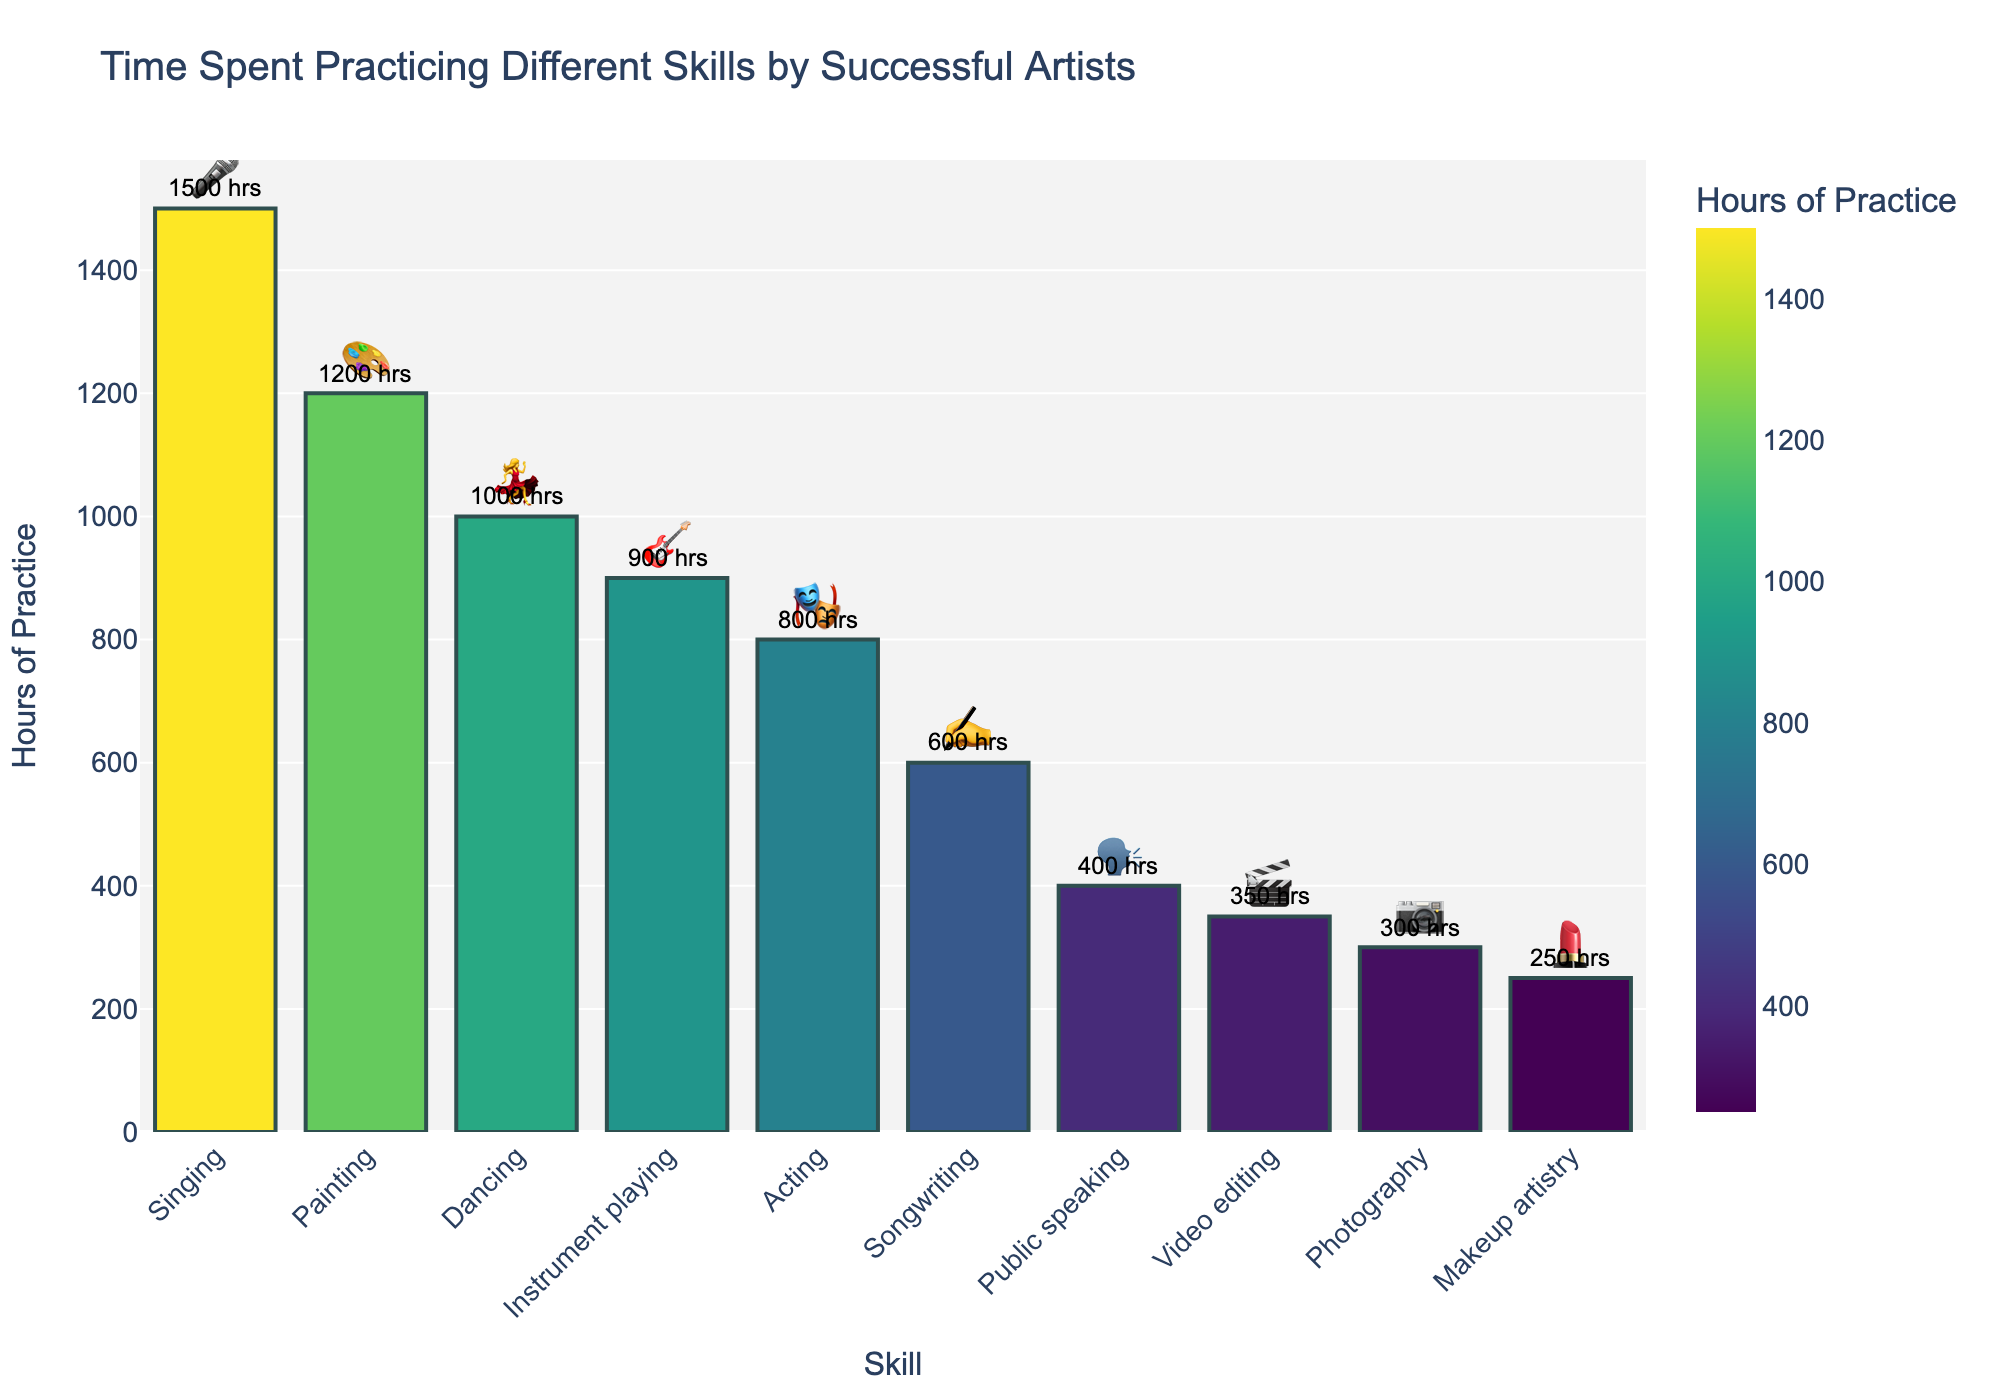what is the skill that artists spend the most hours on? The highest bar on the chart, which is labeled with emoji, represents the skill with the most hours; in this case, "🎤" for Singing.
Answer: Singing What skill has the least amount of practice hours? The lowest bar on the chart. When you look at the hours labeled on the bars, the smallest value is "💄" for Makeup artistry with 250 hours.
Answer: Makeup artistry How many more hours do artists spend on Singing compared to Painting? Locate the bars for Singing and Painting and note their hours: Singing has 1500 hours and Painting has 1200 hours. The difference is 1500 - 1200 = 300 hours.
Answer: 300 What is the sum of hours spent on Acting and Dancing? Identify the hours for Acting and Dancing: Acting has 800 hours, and Dancing has 1000 hours. Add them together: 800 + 1000 = 1800 hours.
Answer: 1800 Which skill ranks third in terms of practice hours? From top to bottom, the third bar represents the third-ranking skill in practice hours. This is Dancing (💃) with 1000 hours.
Answer: Dancing What's the difference in hours between the skill in the fourth position and the last one? The fourth skill is Instrument playing (🎸) with 900 hours, and the last is Makeup artistry (💄) with 250 hours. Subtract the hours: 900 - 250 = 650 hours.
Answer: 650 Which skill do artists practice less, Public speaking or Video editing? Compare the hours of Public speaking (400 hours) and Video editing (350 hours). Video editing has fewer hours.
Answer: Video editing What is the average number of hours spent on Painting, Singing, and Acting? Add the hours for Painting (1200), Singing (1500), and Acting (800). The total is 1200 + 1500 + 800 = 3500. Divide by 3: 3500 / 3 = 1166.67 hours.
Answer: 1166.67 How many skills have more than 900 practice hours? Identify skills with more than 900 hours: Painting (1200), Singing (1500), Dancing (1000)—three skills in total.
Answer: 3 What is the sum of the hours for Songwriting, Photography, and Makeup artistry? Add the hours for Songwriting (600), Photography (300), and Makeup artistry (250). The total is 600 + 300 + 250 = 1150 hours.
Answer: 1150 